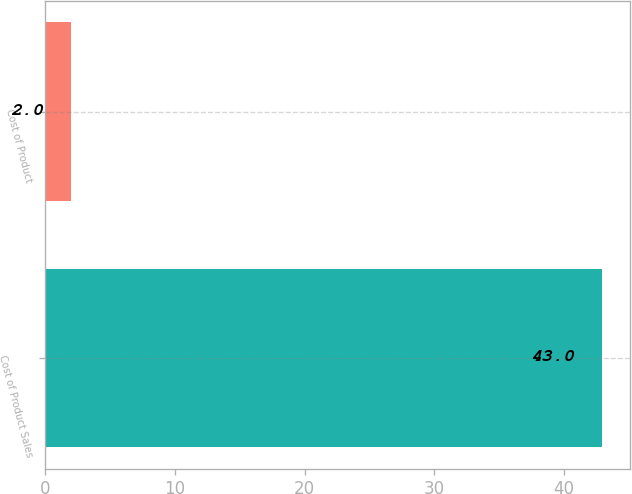Convert chart to OTSL. <chart><loc_0><loc_0><loc_500><loc_500><bar_chart><fcel>Cost of Product Sales<fcel>Cost of Product<nl><fcel>43<fcel>2<nl></chart> 